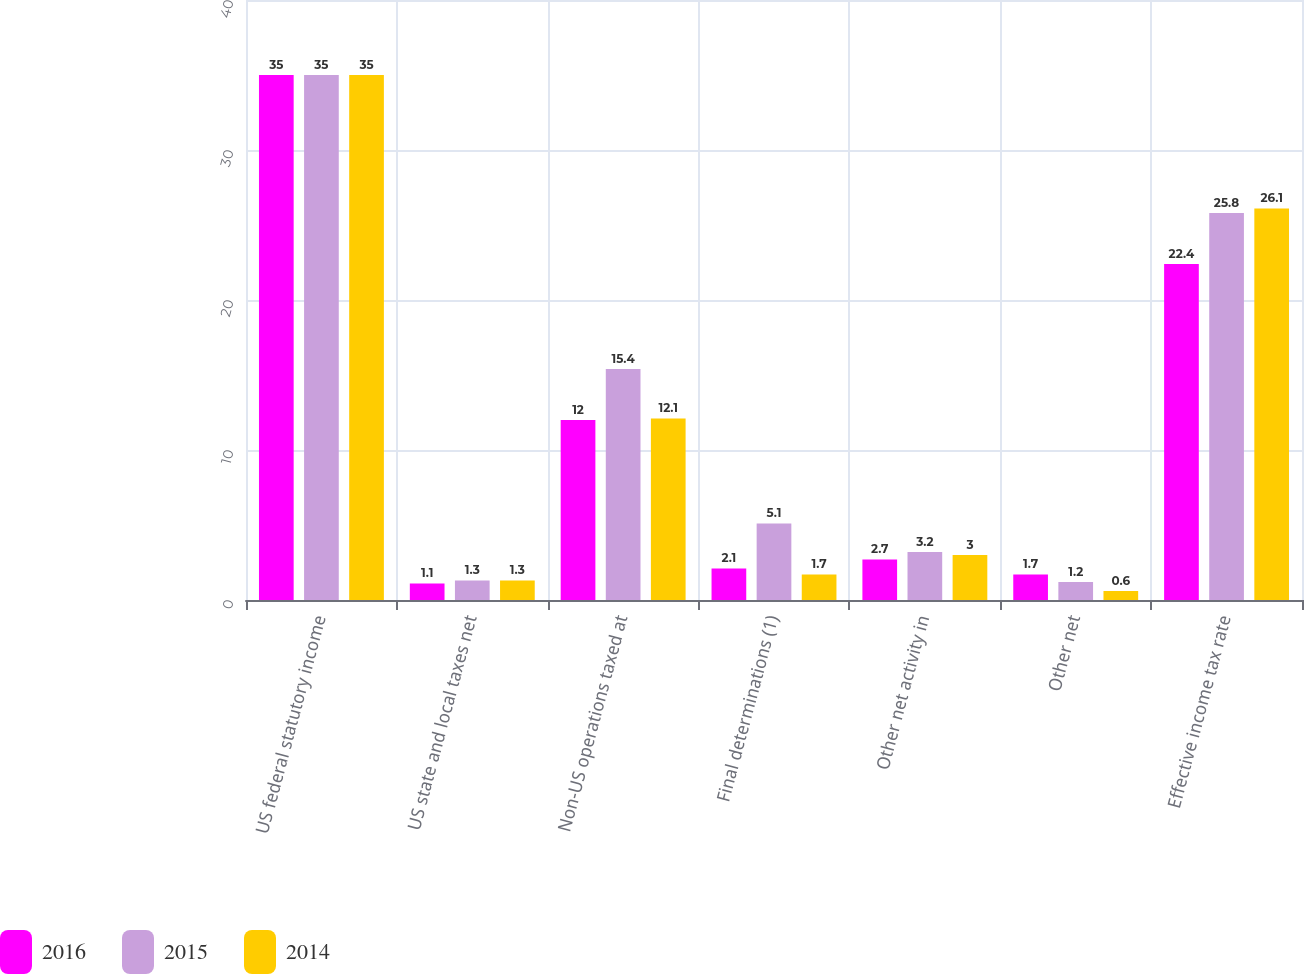Convert chart. <chart><loc_0><loc_0><loc_500><loc_500><stacked_bar_chart><ecel><fcel>US federal statutory income<fcel>US state and local taxes net<fcel>Non-US operations taxed at<fcel>Final determinations (1)<fcel>Other net activity in<fcel>Other net<fcel>Effective income tax rate<nl><fcel>2016<fcel>35<fcel>1.1<fcel>12<fcel>2.1<fcel>2.7<fcel>1.7<fcel>22.4<nl><fcel>2015<fcel>35<fcel>1.3<fcel>15.4<fcel>5.1<fcel>3.2<fcel>1.2<fcel>25.8<nl><fcel>2014<fcel>35<fcel>1.3<fcel>12.1<fcel>1.7<fcel>3<fcel>0.6<fcel>26.1<nl></chart> 